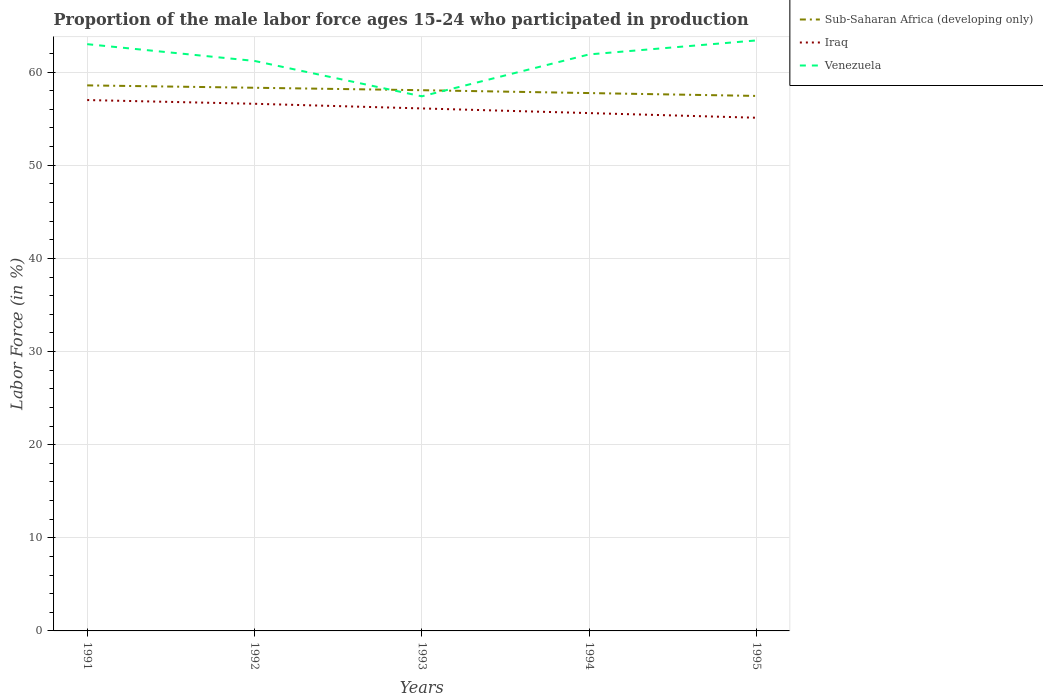Is the number of lines equal to the number of legend labels?
Make the answer very short. Yes. Across all years, what is the maximum proportion of the male labor force who participated in production in Sub-Saharan Africa (developing only)?
Give a very brief answer. 57.44. In which year was the proportion of the male labor force who participated in production in Iraq maximum?
Offer a terse response. 1995. What is the difference between the highest and the lowest proportion of the male labor force who participated in production in Venezuela?
Offer a terse response. 3. How many lines are there?
Your answer should be compact. 3. What is the difference between two consecutive major ticks on the Y-axis?
Your answer should be compact. 10. Are the values on the major ticks of Y-axis written in scientific E-notation?
Your answer should be compact. No. Does the graph contain any zero values?
Your response must be concise. No. Does the graph contain grids?
Offer a very short reply. Yes. How many legend labels are there?
Provide a short and direct response. 3. How are the legend labels stacked?
Give a very brief answer. Vertical. What is the title of the graph?
Give a very brief answer. Proportion of the male labor force ages 15-24 who participated in production. What is the label or title of the X-axis?
Make the answer very short. Years. What is the label or title of the Y-axis?
Your answer should be compact. Labor Force (in %). What is the Labor Force (in %) in Sub-Saharan Africa (developing only) in 1991?
Your response must be concise. 58.57. What is the Labor Force (in %) of Sub-Saharan Africa (developing only) in 1992?
Give a very brief answer. 58.32. What is the Labor Force (in %) of Iraq in 1992?
Make the answer very short. 56.6. What is the Labor Force (in %) in Venezuela in 1992?
Provide a succinct answer. 61.2. What is the Labor Force (in %) of Sub-Saharan Africa (developing only) in 1993?
Make the answer very short. 58.06. What is the Labor Force (in %) in Iraq in 1993?
Keep it short and to the point. 56.1. What is the Labor Force (in %) of Venezuela in 1993?
Keep it short and to the point. 57.4. What is the Labor Force (in %) of Sub-Saharan Africa (developing only) in 1994?
Make the answer very short. 57.75. What is the Labor Force (in %) of Iraq in 1994?
Offer a terse response. 55.6. What is the Labor Force (in %) in Venezuela in 1994?
Provide a short and direct response. 61.9. What is the Labor Force (in %) of Sub-Saharan Africa (developing only) in 1995?
Offer a terse response. 57.44. What is the Labor Force (in %) in Iraq in 1995?
Your answer should be very brief. 55.1. What is the Labor Force (in %) in Venezuela in 1995?
Offer a very short reply. 63.4. Across all years, what is the maximum Labor Force (in %) of Sub-Saharan Africa (developing only)?
Your answer should be compact. 58.57. Across all years, what is the maximum Labor Force (in %) of Venezuela?
Your answer should be compact. 63.4. Across all years, what is the minimum Labor Force (in %) of Sub-Saharan Africa (developing only)?
Provide a succinct answer. 57.44. Across all years, what is the minimum Labor Force (in %) in Iraq?
Offer a terse response. 55.1. Across all years, what is the minimum Labor Force (in %) in Venezuela?
Offer a very short reply. 57.4. What is the total Labor Force (in %) of Sub-Saharan Africa (developing only) in the graph?
Keep it short and to the point. 290.14. What is the total Labor Force (in %) in Iraq in the graph?
Provide a succinct answer. 280.4. What is the total Labor Force (in %) of Venezuela in the graph?
Give a very brief answer. 306.9. What is the difference between the Labor Force (in %) of Sub-Saharan Africa (developing only) in 1991 and that in 1992?
Provide a succinct answer. 0.25. What is the difference between the Labor Force (in %) of Iraq in 1991 and that in 1992?
Your answer should be very brief. 0.4. What is the difference between the Labor Force (in %) of Venezuela in 1991 and that in 1992?
Your answer should be compact. 1.8. What is the difference between the Labor Force (in %) of Sub-Saharan Africa (developing only) in 1991 and that in 1993?
Your response must be concise. 0.52. What is the difference between the Labor Force (in %) of Iraq in 1991 and that in 1993?
Your answer should be very brief. 0.9. What is the difference between the Labor Force (in %) in Venezuela in 1991 and that in 1993?
Offer a terse response. 5.6. What is the difference between the Labor Force (in %) in Sub-Saharan Africa (developing only) in 1991 and that in 1994?
Give a very brief answer. 0.82. What is the difference between the Labor Force (in %) in Iraq in 1991 and that in 1994?
Provide a short and direct response. 1.4. What is the difference between the Labor Force (in %) in Venezuela in 1991 and that in 1994?
Provide a succinct answer. 1.1. What is the difference between the Labor Force (in %) in Sub-Saharan Africa (developing only) in 1991 and that in 1995?
Offer a very short reply. 1.13. What is the difference between the Labor Force (in %) in Iraq in 1991 and that in 1995?
Provide a short and direct response. 1.9. What is the difference between the Labor Force (in %) of Venezuela in 1991 and that in 1995?
Make the answer very short. -0.4. What is the difference between the Labor Force (in %) in Sub-Saharan Africa (developing only) in 1992 and that in 1993?
Offer a very short reply. 0.26. What is the difference between the Labor Force (in %) in Iraq in 1992 and that in 1993?
Your response must be concise. 0.5. What is the difference between the Labor Force (in %) of Sub-Saharan Africa (developing only) in 1992 and that in 1994?
Your response must be concise. 0.57. What is the difference between the Labor Force (in %) in Sub-Saharan Africa (developing only) in 1992 and that in 1995?
Your response must be concise. 0.88. What is the difference between the Labor Force (in %) of Sub-Saharan Africa (developing only) in 1993 and that in 1994?
Make the answer very short. 0.31. What is the difference between the Labor Force (in %) of Iraq in 1993 and that in 1994?
Keep it short and to the point. 0.5. What is the difference between the Labor Force (in %) of Sub-Saharan Africa (developing only) in 1993 and that in 1995?
Provide a succinct answer. 0.61. What is the difference between the Labor Force (in %) of Iraq in 1993 and that in 1995?
Your answer should be compact. 1. What is the difference between the Labor Force (in %) of Venezuela in 1993 and that in 1995?
Provide a short and direct response. -6. What is the difference between the Labor Force (in %) in Sub-Saharan Africa (developing only) in 1994 and that in 1995?
Your answer should be compact. 0.31. What is the difference between the Labor Force (in %) of Sub-Saharan Africa (developing only) in 1991 and the Labor Force (in %) of Iraq in 1992?
Offer a very short reply. 1.97. What is the difference between the Labor Force (in %) in Sub-Saharan Africa (developing only) in 1991 and the Labor Force (in %) in Venezuela in 1992?
Provide a succinct answer. -2.63. What is the difference between the Labor Force (in %) in Iraq in 1991 and the Labor Force (in %) in Venezuela in 1992?
Offer a terse response. -4.2. What is the difference between the Labor Force (in %) in Sub-Saharan Africa (developing only) in 1991 and the Labor Force (in %) in Iraq in 1993?
Make the answer very short. 2.47. What is the difference between the Labor Force (in %) of Sub-Saharan Africa (developing only) in 1991 and the Labor Force (in %) of Venezuela in 1993?
Your response must be concise. 1.17. What is the difference between the Labor Force (in %) of Iraq in 1991 and the Labor Force (in %) of Venezuela in 1993?
Offer a terse response. -0.4. What is the difference between the Labor Force (in %) in Sub-Saharan Africa (developing only) in 1991 and the Labor Force (in %) in Iraq in 1994?
Your answer should be compact. 2.97. What is the difference between the Labor Force (in %) in Sub-Saharan Africa (developing only) in 1991 and the Labor Force (in %) in Venezuela in 1994?
Ensure brevity in your answer.  -3.33. What is the difference between the Labor Force (in %) of Iraq in 1991 and the Labor Force (in %) of Venezuela in 1994?
Ensure brevity in your answer.  -4.9. What is the difference between the Labor Force (in %) of Sub-Saharan Africa (developing only) in 1991 and the Labor Force (in %) of Iraq in 1995?
Offer a very short reply. 3.47. What is the difference between the Labor Force (in %) of Sub-Saharan Africa (developing only) in 1991 and the Labor Force (in %) of Venezuela in 1995?
Provide a succinct answer. -4.83. What is the difference between the Labor Force (in %) in Iraq in 1991 and the Labor Force (in %) in Venezuela in 1995?
Your answer should be compact. -6.4. What is the difference between the Labor Force (in %) of Sub-Saharan Africa (developing only) in 1992 and the Labor Force (in %) of Iraq in 1993?
Ensure brevity in your answer.  2.22. What is the difference between the Labor Force (in %) in Sub-Saharan Africa (developing only) in 1992 and the Labor Force (in %) in Venezuela in 1993?
Your response must be concise. 0.92. What is the difference between the Labor Force (in %) in Sub-Saharan Africa (developing only) in 1992 and the Labor Force (in %) in Iraq in 1994?
Provide a succinct answer. 2.72. What is the difference between the Labor Force (in %) in Sub-Saharan Africa (developing only) in 1992 and the Labor Force (in %) in Venezuela in 1994?
Your answer should be very brief. -3.58. What is the difference between the Labor Force (in %) of Iraq in 1992 and the Labor Force (in %) of Venezuela in 1994?
Keep it short and to the point. -5.3. What is the difference between the Labor Force (in %) of Sub-Saharan Africa (developing only) in 1992 and the Labor Force (in %) of Iraq in 1995?
Provide a succinct answer. 3.22. What is the difference between the Labor Force (in %) of Sub-Saharan Africa (developing only) in 1992 and the Labor Force (in %) of Venezuela in 1995?
Give a very brief answer. -5.08. What is the difference between the Labor Force (in %) of Sub-Saharan Africa (developing only) in 1993 and the Labor Force (in %) of Iraq in 1994?
Provide a succinct answer. 2.46. What is the difference between the Labor Force (in %) of Sub-Saharan Africa (developing only) in 1993 and the Labor Force (in %) of Venezuela in 1994?
Your answer should be compact. -3.84. What is the difference between the Labor Force (in %) in Iraq in 1993 and the Labor Force (in %) in Venezuela in 1994?
Ensure brevity in your answer.  -5.8. What is the difference between the Labor Force (in %) of Sub-Saharan Africa (developing only) in 1993 and the Labor Force (in %) of Iraq in 1995?
Your answer should be very brief. 2.96. What is the difference between the Labor Force (in %) of Sub-Saharan Africa (developing only) in 1993 and the Labor Force (in %) of Venezuela in 1995?
Offer a terse response. -5.34. What is the difference between the Labor Force (in %) in Sub-Saharan Africa (developing only) in 1994 and the Labor Force (in %) in Iraq in 1995?
Your response must be concise. 2.65. What is the difference between the Labor Force (in %) of Sub-Saharan Africa (developing only) in 1994 and the Labor Force (in %) of Venezuela in 1995?
Ensure brevity in your answer.  -5.65. What is the difference between the Labor Force (in %) in Iraq in 1994 and the Labor Force (in %) in Venezuela in 1995?
Provide a succinct answer. -7.8. What is the average Labor Force (in %) of Sub-Saharan Africa (developing only) per year?
Your answer should be compact. 58.03. What is the average Labor Force (in %) of Iraq per year?
Give a very brief answer. 56.08. What is the average Labor Force (in %) in Venezuela per year?
Offer a terse response. 61.38. In the year 1991, what is the difference between the Labor Force (in %) in Sub-Saharan Africa (developing only) and Labor Force (in %) in Iraq?
Keep it short and to the point. 1.57. In the year 1991, what is the difference between the Labor Force (in %) in Sub-Saharan Africa (developing only) and Labor Force (in %) in Venezuela?
Give a very brief answer. -4.43. In the year 1991, what is the difference between the Labor Force (in %) of Iraq and Labor Force (in %) of Venezuela?
Provide a succinct answer. -6. In the year 1992, what is the difference between the Labor Force (in %) in Sub-Saharan Africa (developing only) and Labor Force (in %) in Iraq?
Provide a succinct answer. 1.72. In the year 1992, what is the difference between the Labor Force (in %) in Sub-Saharan Africa (developing only) and Labor Force (in %) in Venezuela?
Provide a succinct answer. -2.88. In the year 1993, what is the difference between the Labor Force (in %) of Sub-Saharan Africa (developing only) and Labor Force (in %) of Iraq?
Keep it short and to the point. 1.96. In the year 1993, what is the difference between the Labor Force (in %) of Sub-Saharan Africa (developing only) and Labor Force (in %) of Venezuela?
Make the answer very short. 0.66. In the year 1993, what is the difference between the Labor Force (in %) of Iraq and Labor Force (in %) of Venezuela?
Provide a short and direct response. -1.3. In the year 1994, what is the difference between the Labor Force (in %) in Sub-Saharan Africa (developing only) and Labor Force (in %) in Iraq?
Provide a succinct answer. 2.15. In the year 1994, what is the difference between the Labor Force (in %) in Sub-Saharan Africa (developing only) and Labor Force (in %) in Venezuela?
Provide a short and direct response. -4.15. In the year 1995, what is the difference between the Labor Force (in %) in Sub-Saharan Africa (developing only) and Labor Force (in %) in Iraq?
Provide a succinct answer. 2.34. In the year 1995, what is the difference between the Labor Force (in %) of Sub-Saharan Africa (developing only) and Labor Force (in %) of Venezuela?
Your response must be concise. -5.96. What is the ratio of the Labor Force (in %) of Sub-Saharan Africa (developing only) in 1991 to that in 1992?
Your response must be concise. 1. What is the ratio of the Labor Force (in %) in Iraq in 1991 to that in 1992?
Your answer should be very brief. 1.01. What is the ratio of the Labor Force (in %) of Venezuela in 1991 to that in 1992?
Make the answer very short. 1.03. What is the ratio of the Labor Force (in %) of Sub-Saharan Africa (developing only) in 1991 to that in 1993?
Your response must be concise. 1.01. What is the ratio of the Labor Force (in %) in Venezuela in 1991 to that in 1993?
Ensure brevity in your answer.  1.1. What is the ratio of the Labor Force (in %) of Sub-Saharan Africa (developing only) in 1991 to that in 1994?
Offer a terse response. 1.01. What is the ratio of the Labor Force (in %) of Iraq in 1991 to that in 1994?
Give a very brief answer. 1.03. What is the ratio of the Labor Force (in %) of Venezuela in 1991 to that in 1994?
Your answer should be very brief. 1.02. What is the ratio of the Labor Force (in %) in Sub-Saharan Africa (developing only) in 1991 to that in 1995?
Offer a very short reply. 1.02. What is the ratio of the Labor Force (in %) in Iraq in 1991 to that in 1995?
Give a very brief answer. 1.03. What is the ratio of the Labor Force (in %) in Iraq in 1992 to that in 1993?
Give a very brief answer. 1.01. What is the ratio of the Labor Force (in %) in Venezuela in 1992 to that in 1993?
Offer a terse response. 1.07. What is the ratio of the Labor Force (in %) in Sub-Saharan Africa (developing only) in 1992 to that in 1994?
Ensure brevity in your answer.  1.01. What is the ratio of the Labor Force (in %) in Venezuela in 1992 to that in 1994?
Offer a terse response. 0.99. What is the ratio of the Labor Force (in %) of Sub-Saharan Africa (developing only) in 1992 to that in 1995?
Your response must be concise. 1.02. What is the ratio of the Labor Force (in %) in Iraq in 1992 to that in 1995?
Ensure brevity in your answer.  1.03. What is the ratio of the Labor Force (in %) of Venezuela in 1992 to that in 1995?
Provide a succinct answer. 0.97. What is the ratio of the Labor Force (in %) of Iraq in 1993 to that in 1994?
Ensure brevity in your answer.  1.01. What is the ratio of the Labor Force (in %) of Venezuela in 1993 to that in 1994?
Make the answer very short. 0.93. What is the ratio of the Labor Force (in %) in Sub-Saharan Africa (developing only) in 1993 to that in 1995?
Keep it short and to the point. 1.01. What is the ratio of the Labor Force (in %) of Iraq in 1993 to that in 1995?
Your answer should be very brief. 1.02. What is the ratio of the Labor Force (in %) in Venezuela in 1993 to that in 1995?
Offer a very short reply. 0.91. What is the ratio of the Labor Force (in %) of Sub-Saharan Africa (developing only) in 1994 to that in 1995?
Offer a very short reply. 1.01. What is the ratio of the Labor Force (in %) of Iraq in 1994 to that in 1995?
Ensure brevity in your answer.  1.01. What is the ratio of the Labor Force (in %) of Venezuela in 1994 to that in 1995?
Your answer should be very brief. 0.98. What is the difference between the highest and the second highest Labor Force (in %) of Sub-Saharan Africa (developing only)?
Keep it short and to the point. 0.25. What is the difference between the highest and the second highest Labor Force (in %) in Venezuela?
Ensure brevity in your answer.  0.4. What is the difference between the highest and the lowest Labor Force (in %) of Sub-Saharan Africa (developing only)?
Your answer should be very brief. 1.13. What is the difference between the highest and the lowest Labor Force (in %) in Iraq?
Your response must be concise. 1.9. 